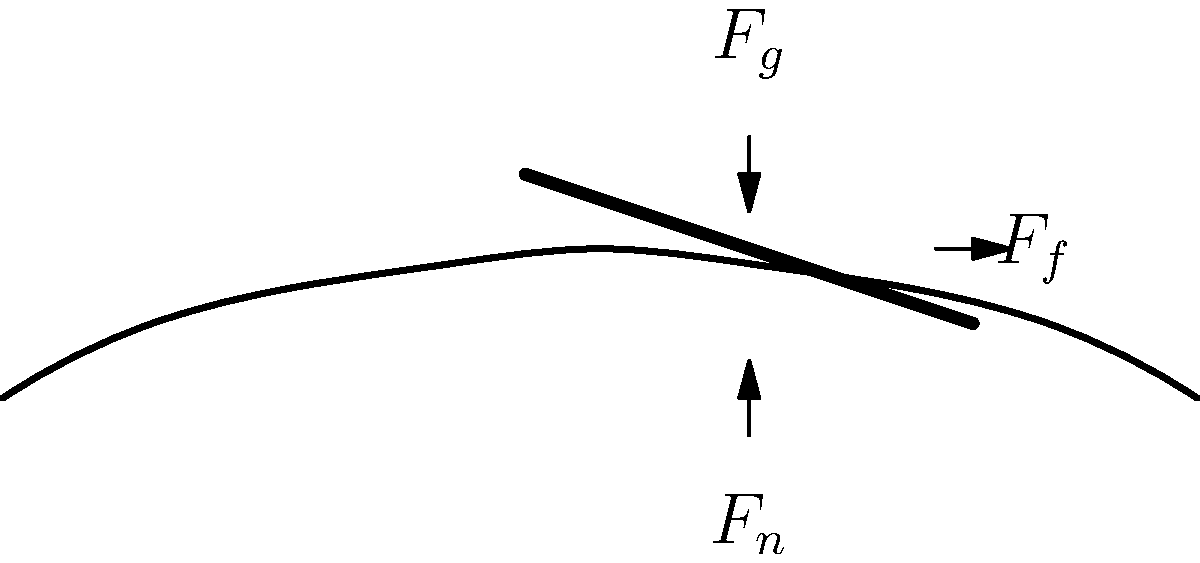During a long writing session, a radio scriptwriter experiences biomechanical stress on their hand. Given that the writer applies a downward force ($F_g$) of 5 N while writing, and the coefficient of friction ($\mu$) between the pen and paper is 0.4, calculate the frictional force ($F_f$) acting on the pen. Assume the normal force ($F_n$) is equal in magnitude to $F_g$. To solve this problem, we'll follow these steps:

1. Identify the given information:
   - Downward force ($F_g$) = 5 N
   - Coefficient of friction ($\mu$) = 0.4
   - Normal force ($F_n$) = $F_g$ = 5 N (since they are equal in magnitude)

2. Recall the formula for frictional force:
   $F_f = \mu \cdot F_n$

3. Substitute the known values into the formula:
   $F_f = 0.4 \cdot 5\text{ N}$

4. Calculate the frictional force:
   $F_f = 2\text{ N}$

This frictional force represents the biomechanical stress experienced by the writer's hand as it moves across the paper during long writing sessions. Understanding this force can help in developing ergonomic writing tools and techniques to reduce hand fatigue and potential repetitive strain injuries for writers.
Answer: 2 N 